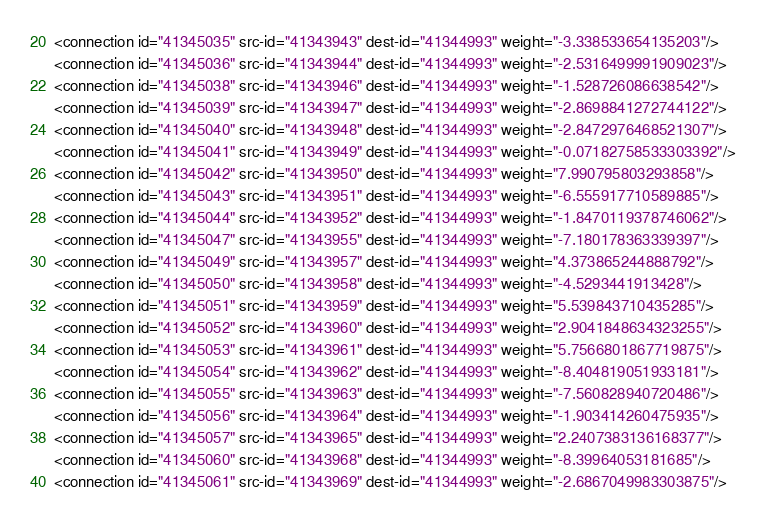Convert code to text. <code><loc_0><loc_0><loc_500><loc_500><_XML_><connection id="41345035" src-id="41343943" dest-id="41344993" weight="-3.338533654135203"/>
<connection id="41345036" src-id="41343944" dest-id="41344993" weight="-2.5316499991909023"/>
<connection id="41345038" src-id="41343946" dest-id="41344993" weight="-1.528726086638542"/>
<connection id="41345039" src-id="41343947" dest-id="41344993" weight="-2.8698841272744122"/>
<connection id="41345040" src-id="41343948" dest-id="41344993" weight="-2.8472976468521307"/>
<connection id="41345041" src-id="41343949" dest-id="41344993" weight="-0.07182758533303392"/>
<connection id="41345042" src-id="41343950" dest-id="41344993" weight="7.990795803293858"/>
<connection id="41345043" src-id="41343951" dest-id="41344993" weight="-6.555917710589885"/>
<connection id="41345044" src-id="41343952" dest-id="41344993" weight="-1.8470119378746062"/>
<connection id="41345047" src-id="41343955" dest-id="41344993" weight="-7.180178363339397"/>
<connection id="41345049" src-id="41343957" dest-id="41344993" weight="4.373865244888792"/>
<connection id="41345050" src-id="41343958" dest-id="41344993" weight="-4.5293441913428"/>
<connection id="41345051" src-id="41343959" dest-id="41344993" weight="5.539843710435285"/>
<connection id="41345052" src-id="41343960" dest-id="41344993" weight="2.9041848634323255"/>
<connection id="41345053" src-id="41343961" dest-id="41344993" weight="5.7566801867719875"/>
<connection id="41345054" src-id="41343962" dest-id="41344993" weight="-8.404819051933181"/>
<connection id="41345055" src-id="41343963" dest-id="41344993" weight="-7.560828940720486"/>
<connection id="41345056" src-id="41343964" dest-id="41344993" weight="-1.903414260475935"/>
<connection id="41345057" src-id="41343965" dest-id="41344993" weight="2.2407383136168377"/>
<connection id="41345060" src-id="41343968" dest-id="41344993" weight="-8.39964053181685"/>
<connection id="41345061" src-id="41343969" dest-id="41344993" weight="-2.6867049983303875"/></code> 